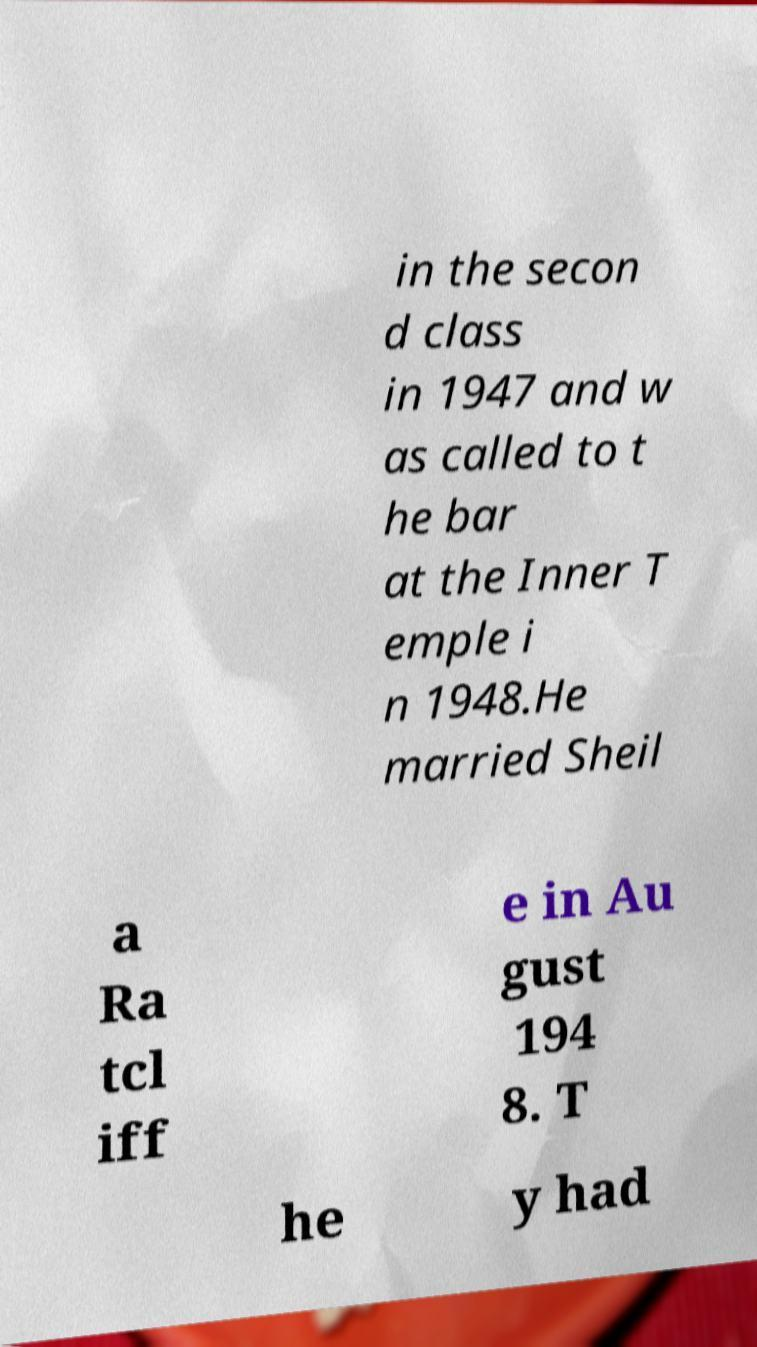I need the written content from this picture converted into text. Can you do that? in the secon d class in 1947 and w as called to t he bar at the Inner T emple i n 1948.He married Sheil a Ra tcl iff e in Au gust 194 8. T he y had 